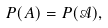Convert formula to latex. <formula><loc_0><loc_0><loc_500><loc_500>P ( A ) = P ( \mathcal { A } ) ,</formula> 